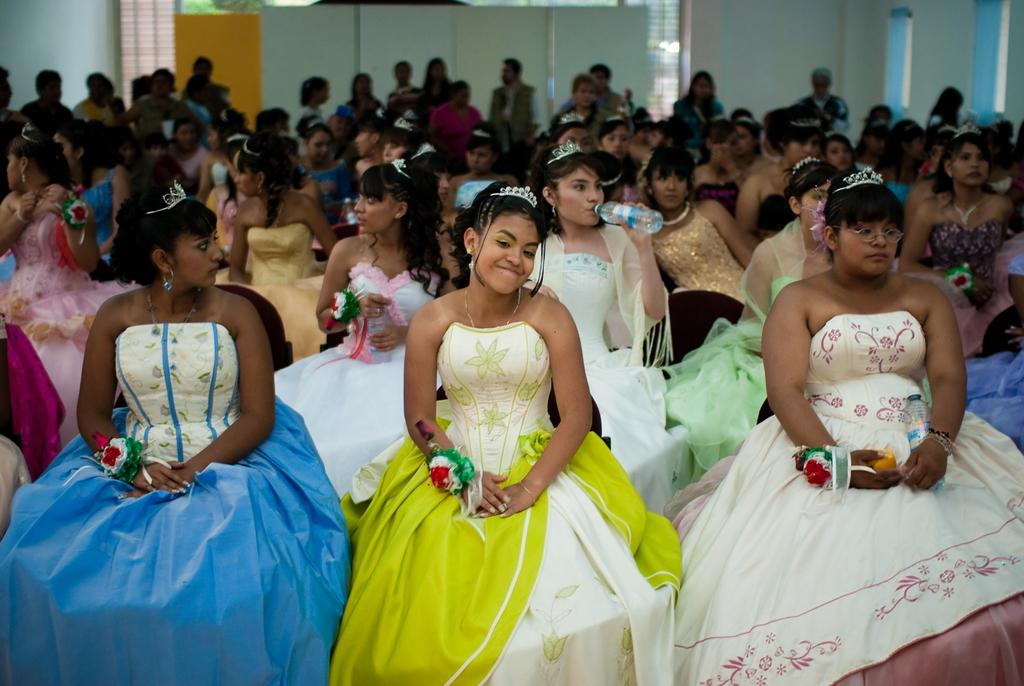How many people are in the image? There is a group of people in the image. What is the woman in the image doing? The woman is sitting and drinking. What can be seen in the background of the image? There are windows in the background of the image. What is visible behind the windows? Trees are visible behind the windows. How many cows are visible through the windows in the image? There are no cows visible through the windows in the image; only trees are visible. 